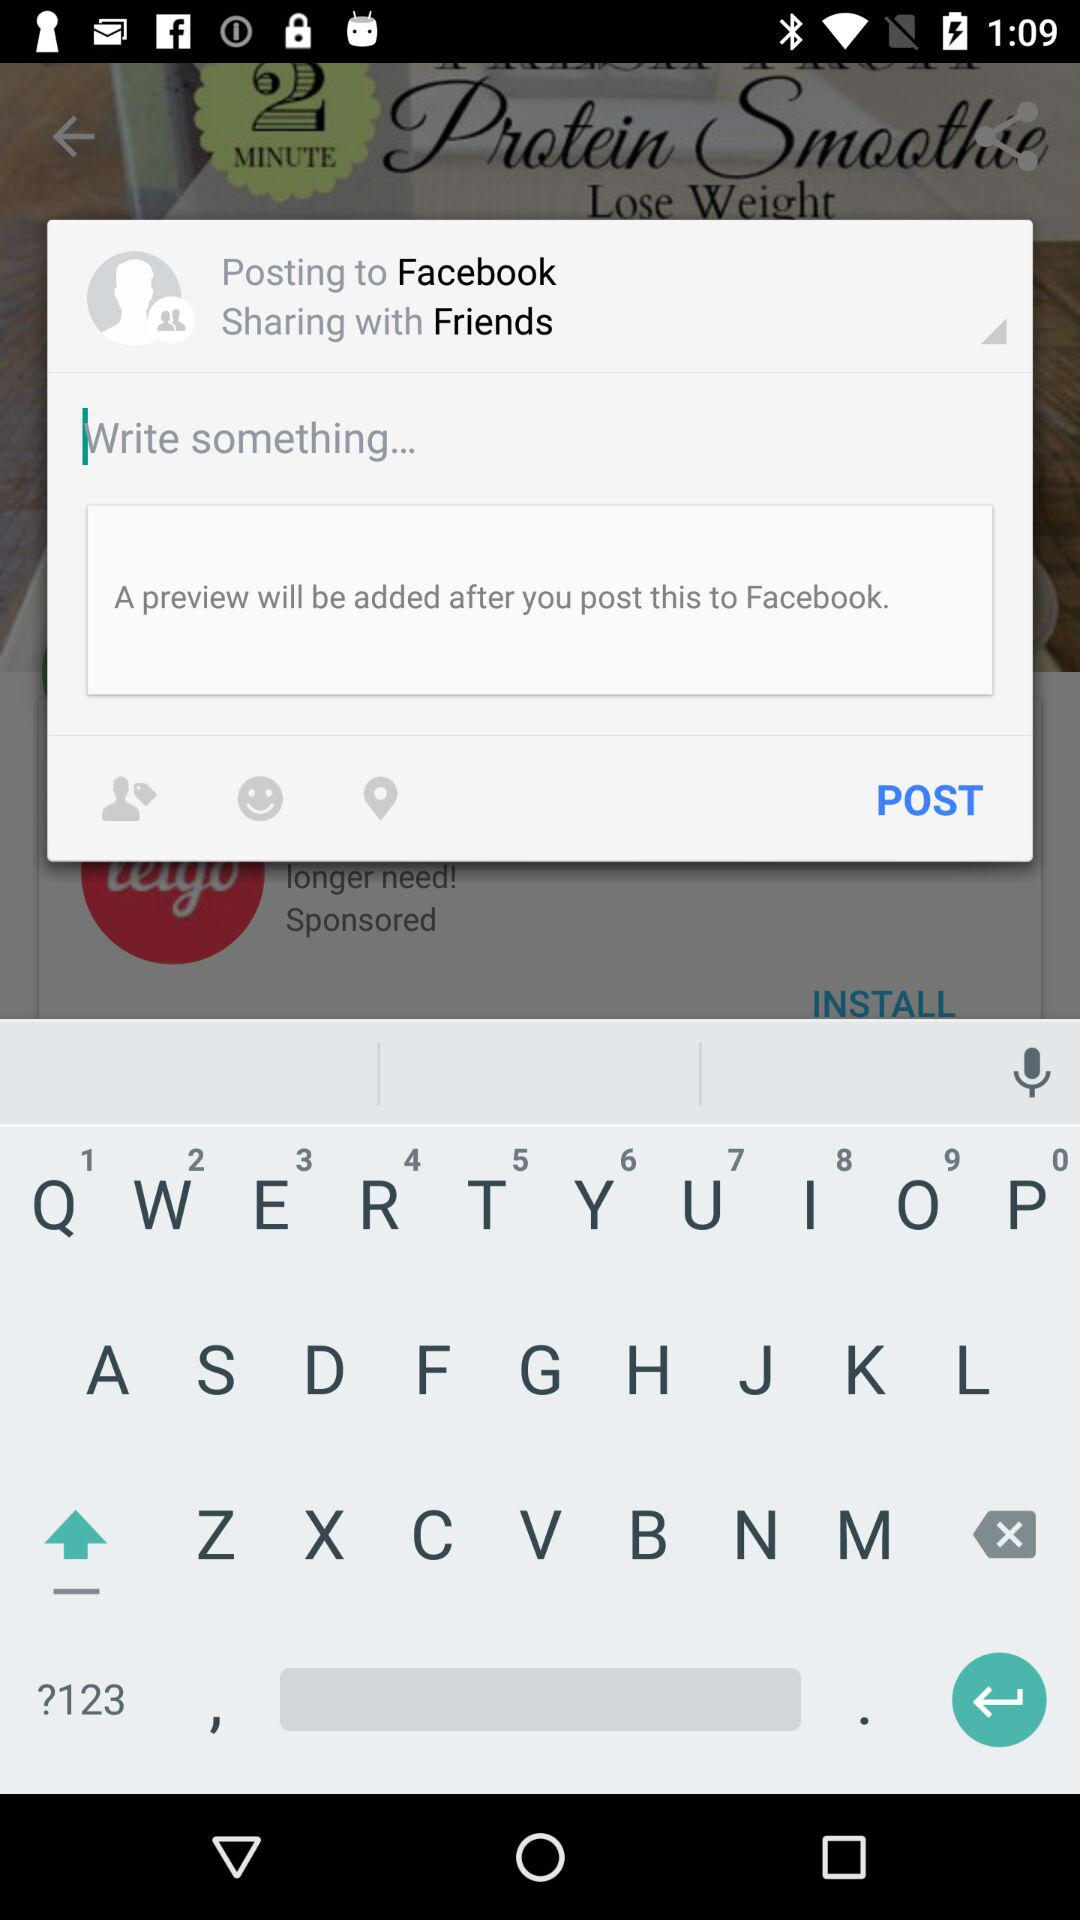What language is selected? The selected language is English (recommended). 